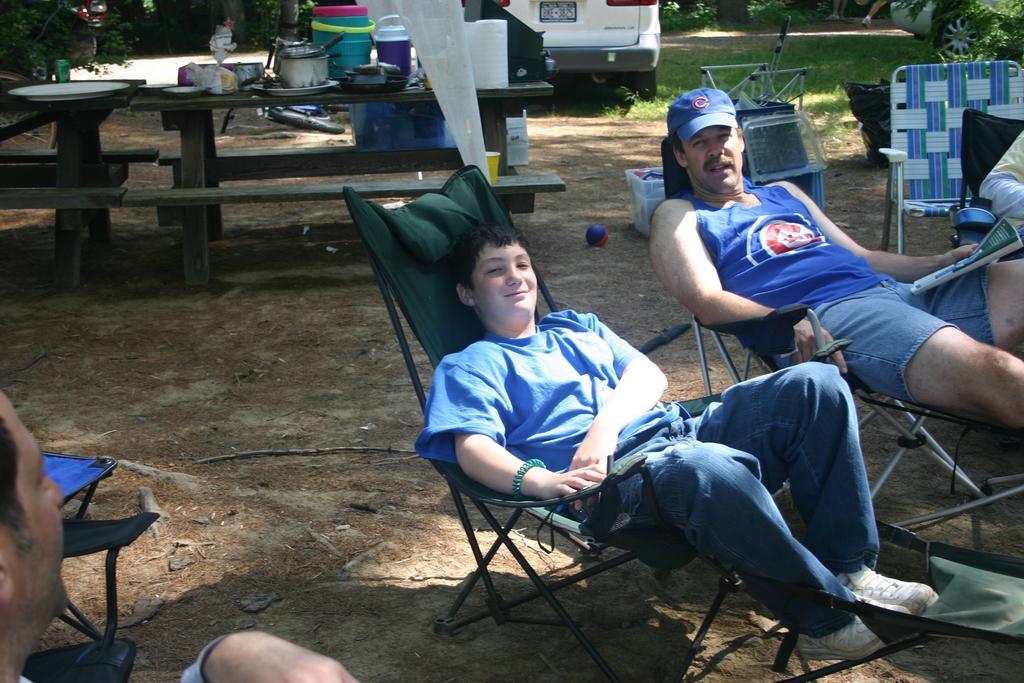How would you summarize this image in a sentence or two? In this picture there is a table at the top right side of the image on which there are kitchenware, and there is a car at the center of the image and the people those who are sitting on the chairs at the right side of the image, there is a ball on the floor and the person who is sitting at the right side of the image he is holding a news paper in his hand, there are some trees around the area of the image. 